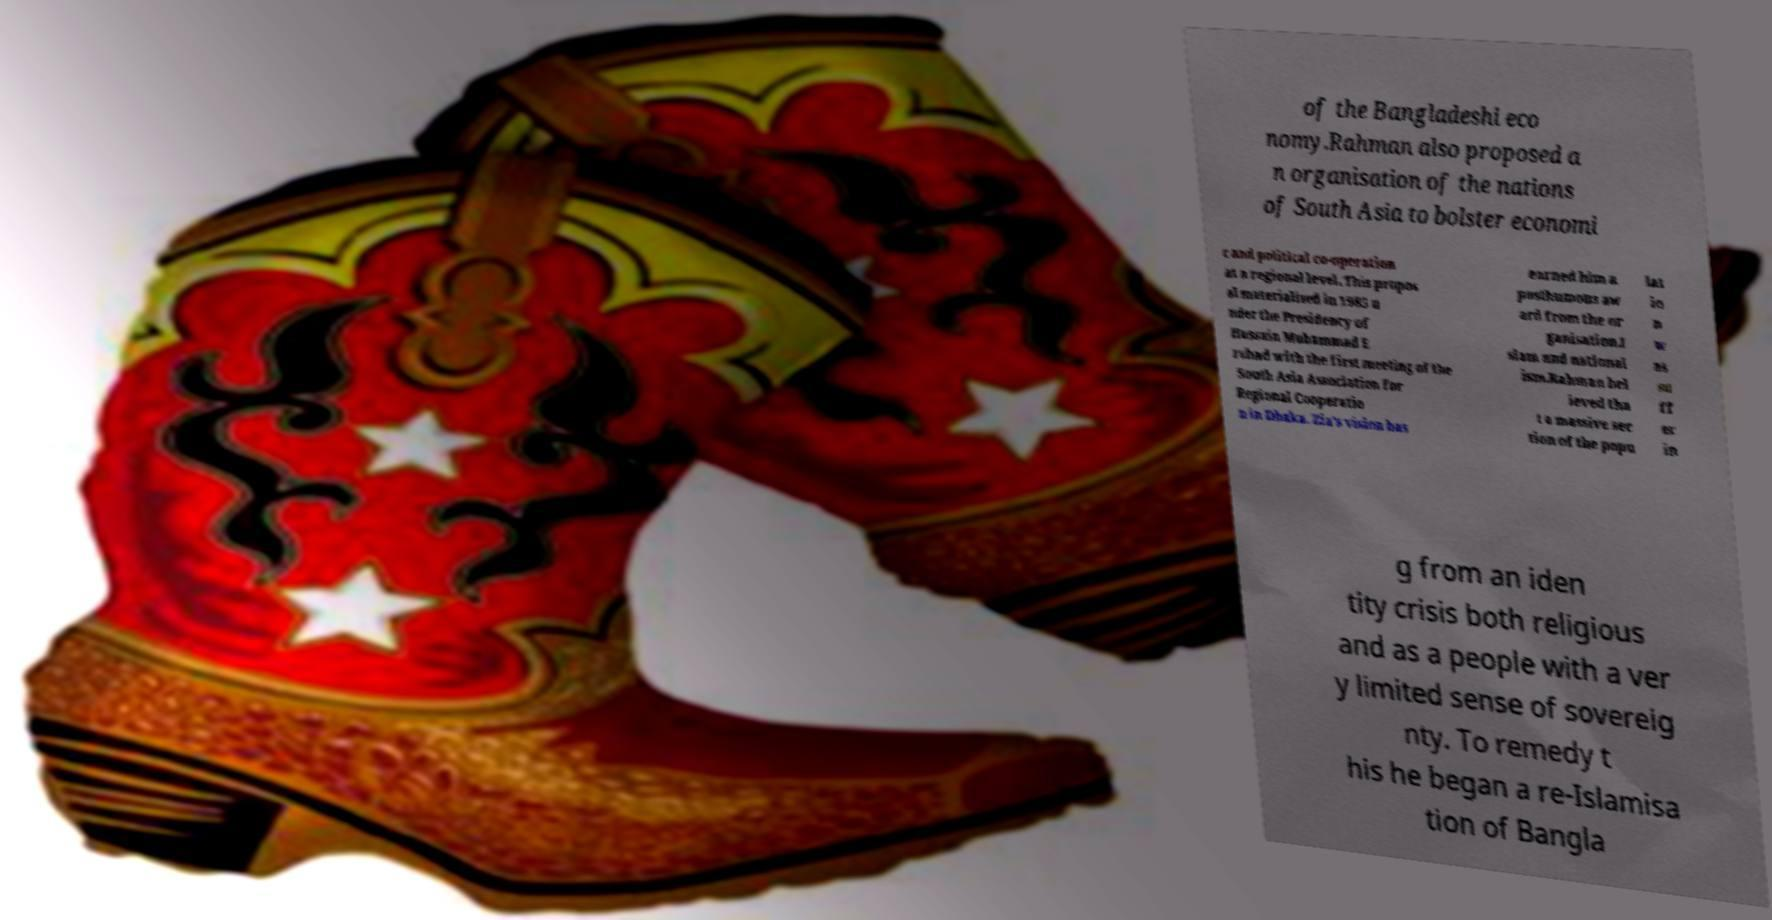Could you extract and type out the text from this image? of the Bangladeshi eco nomy.Rahman also proposed a n organisation of the nations of South Asia to bolster economi c and political co-operation at a regional level. This propos al materialised in 1985 u nder the Presidency of Hussain Muhammad E rshad with the first meeting of the South Asia Association for Regional Cooperatio n in Dhaka. Zia's vision has earned him a posthumous aw ard from the or ganisation.I slam and national ism.Rahman bel ieved tha t a massive sec tion of the popu lat io n w as su ff er in g from an iden tity crisis both religious and as a people with a ver y limited sense of sovereig nty. To remedy t his he began a re-Islamisa tion of Bangla 